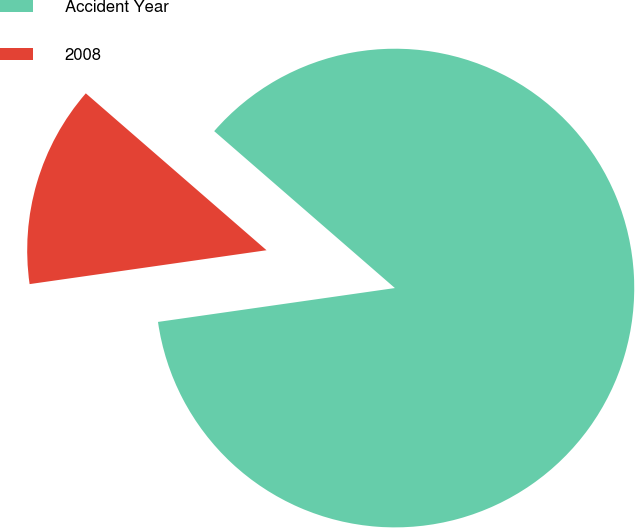Convert chart. <chart><loc_0><loc_0><loc_500><loc_500><pie_chart><fcel>Accident Year<fcel>2008<nl><fcel>86.36%<fcel>13.64%<nl></chart> 